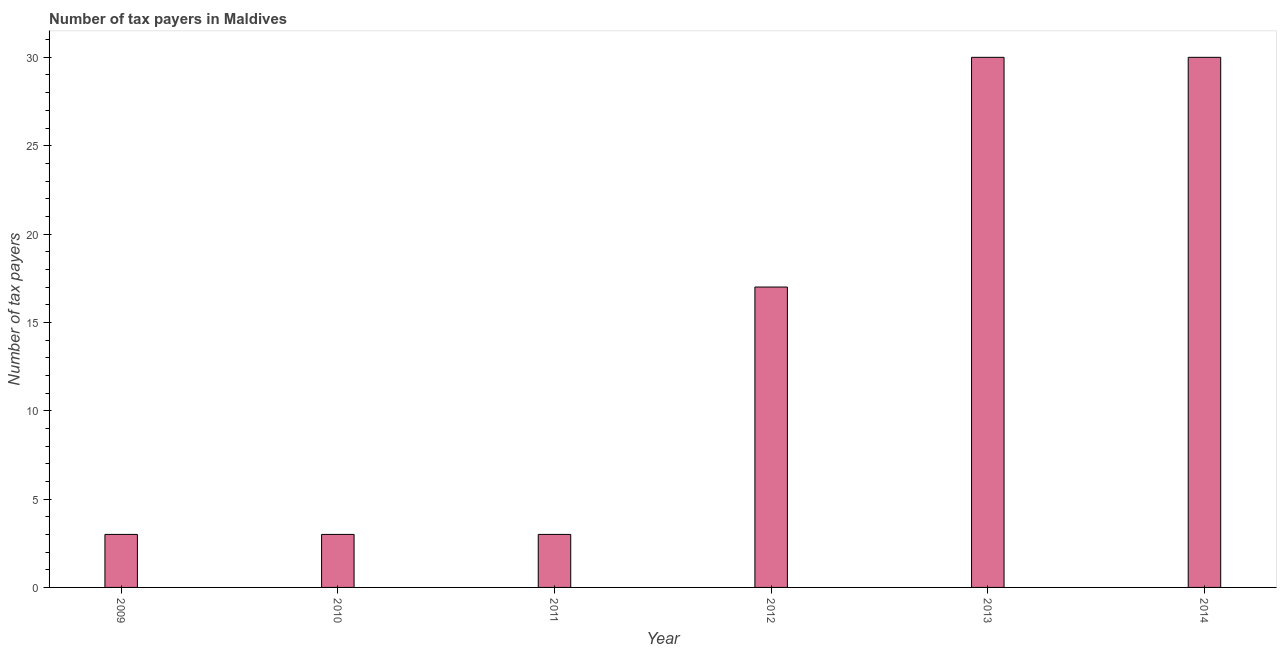What is the title of the graph?
Keep it short and to the point. Number of tax payers in Maldives. What is the label or title of the Y-axis?
Offer a terse response. Number of tax payers. Across all years, what is the maximum number of tax payers?
Offer a very short reply. 30. Across all years, what is the minimum number of tax payers?
Offer a very short reply. 3. What is the sum of the number of tax payers?
Your answer should be very brief. 86. Do a majority of the years between 2014 and 2011 (inclusive) have number of tax payers greater than 2 ?
Offer a very short reply. Yes. What is the ratio of the number of tax payers in 2012 to that in 2013?
Make the answer very short. 0.57. Is the number of tax payers in 2011 less than that in 2013?
Offer a very short reply. Yes. Is the sum of the number of tax payers in 2009 and 2014 greater than the maximum number of tax payers across all years?
Ensure brevity in your answer.  Yes. In how many years, is the number of tax payers greater than the average number of tax payers taken over all years?
Make the answer very short. 3. Are all the bars in the graph horizontal?
Offer a very short reply. No. What is the difference between two consecutive major ticks on the Y-axis?
Offer a terse response. 5. What is the Number of tax payers in 2009?
Provide a succinct answer. 3. What is the Number of tax payers of 2011?
Provide a short and direct response. 3. What is the Number of tax payers of 2012?
Give a very brief answer. 17. What is the Number of tax payers of 2013?
Provide a short and direct response. 30. What is the difference between the Number of tax payers in 2009 and 2010?
Offer a very short reply. 0. What is the difference between the Number of tax payers in 2009 and 2011?
Offer a terse response. 0. What is the difference between the Number of tax payers in 2009 and 2012?
Provide a succinct answer. -14. What is the difference between the Number of tax payers in 2009 and 2013?
Offer a very short reply. -27. What is the difference between the Number of tax payers in 2009 and 2014?
Your response must be concise. -27. What is the difference between the Number of tax payers in 2010 and 2011?
Give a very brief answer. 0. What is the difference between the Number of tax payers in 2010 and 2012?
Your answer should be compact. -14. What is the difference between the Number of tax payers in 2010 and 2013?
Give a very brief answer. -27. What is the difference between the Number of tax payers in 2011 and 2012?
Your answer should be very brief. -14. What is the difference between the Number of tax payers in 2011 and 2014?
Offer a very short reply. -27. What is the difference between the Number of tax payers in 2013 and 2014?
Give a very brief answer. 0. What is the ratio of the Number of tax payers in 2009 to that in 2010?
Your answer should be compact. 1. What is the ratio of the Number of tax payers in 2009 to that in 2011?
Offer a very short reply. 1. What is the ratio of the Number of tax payers in 2009 to that in 2012?
Offer a very short reply. 0.18. What is the ratio of the Number of tax payers in 2010 to that in 2011?
Your answer should be compact. 1. What is the ratio of the Number of tax payers in 2010 to that in 2012?
Your answer should be compact. 0.18. What is the ratio of the Number of tax payers in 2011 to that in 2012?
Provide a succinct answer. 0.18. What is the ratio of the Number of tax payers in 2011 to that in 2014?
Provide a succinct answer. 0.1. What is the ratio of the Number of tax payers in 2012 to that in 2013?
Offer a very short reply. 0.57. What is the ratio of the Number of tax payers in 2012 to that in 2014?
Keep it short and to the point. 0.57. What is the ratio of the Number of tax payers in 2013 to that in 2014?
Your answer should be very brief. 1. 